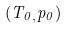<formula> <loc_0><loc_0><loc_500><loc_500>( T _ { 0 , } p _ { 0 } )</formula> 